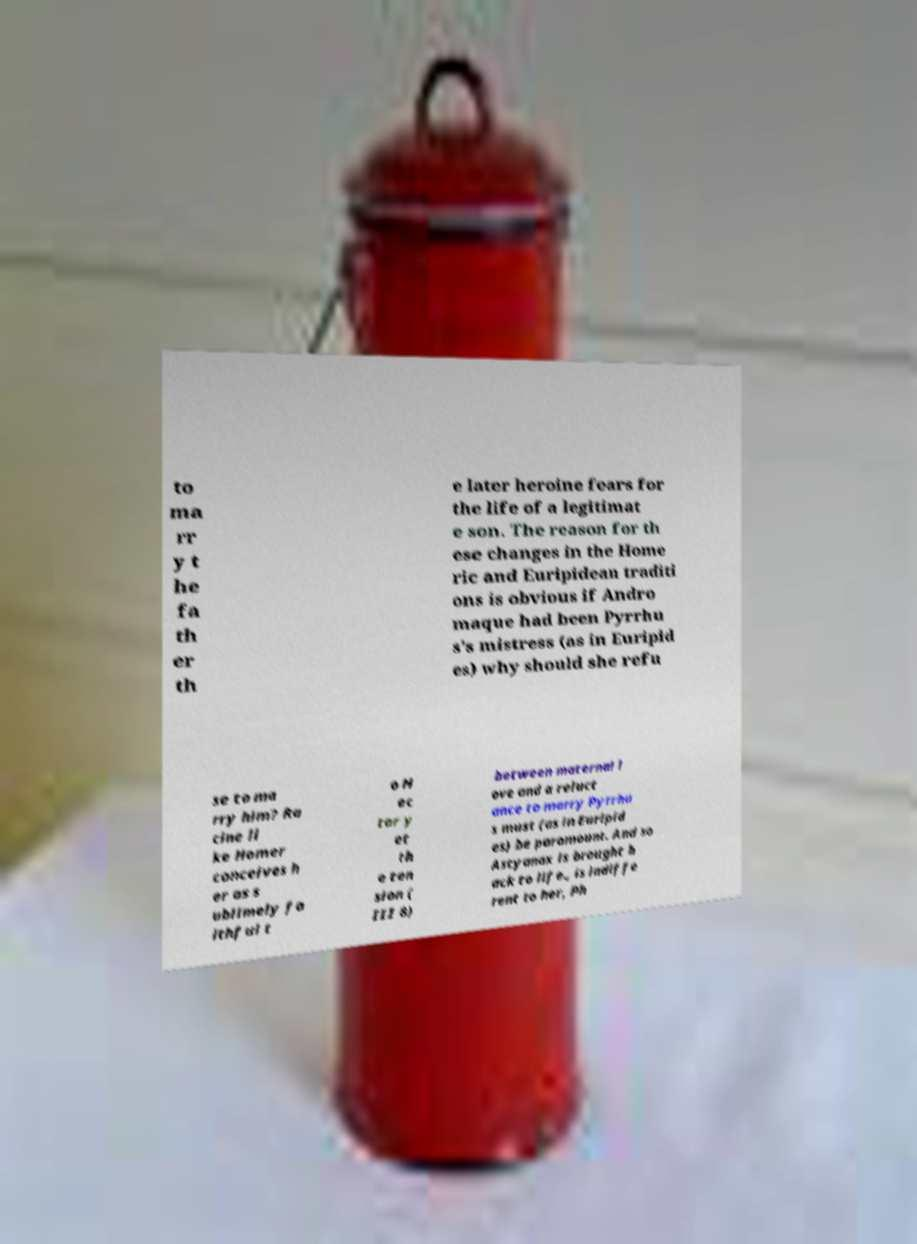Could you extract and type out the text from this image? to ma rr y t he fa th er th e later heroine fears for the life of a legitimat e son. The reason for th ese changes in the Home ric and Euripidean traditi ons is obvious if Andro maque had been Pyrrhu s's mistress (as in Euripid es) why should she refu se to ma rry him? Ra cine li ke Homer conceives h er as s ublimely fa ithful t o H ec tor y et th e ten sion ( III 8) between maternal l ove and a reluct ance to marry Pyrrhu s must (as in Euripid es) be paramount. And so Astyanax is brought b ack to life., is indiffe rent to her, Ph 